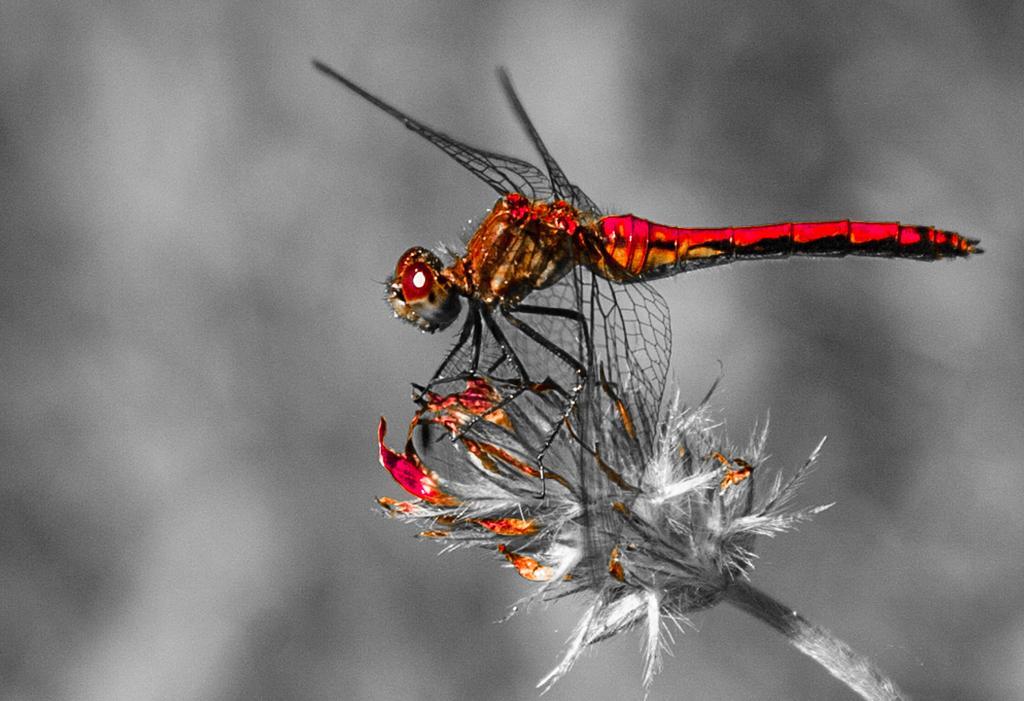In one or two sentences, can you explain what this image depicts? In this picture there is a dragonfly on the flower. At the back the image is blurry. This is an edited picture. 